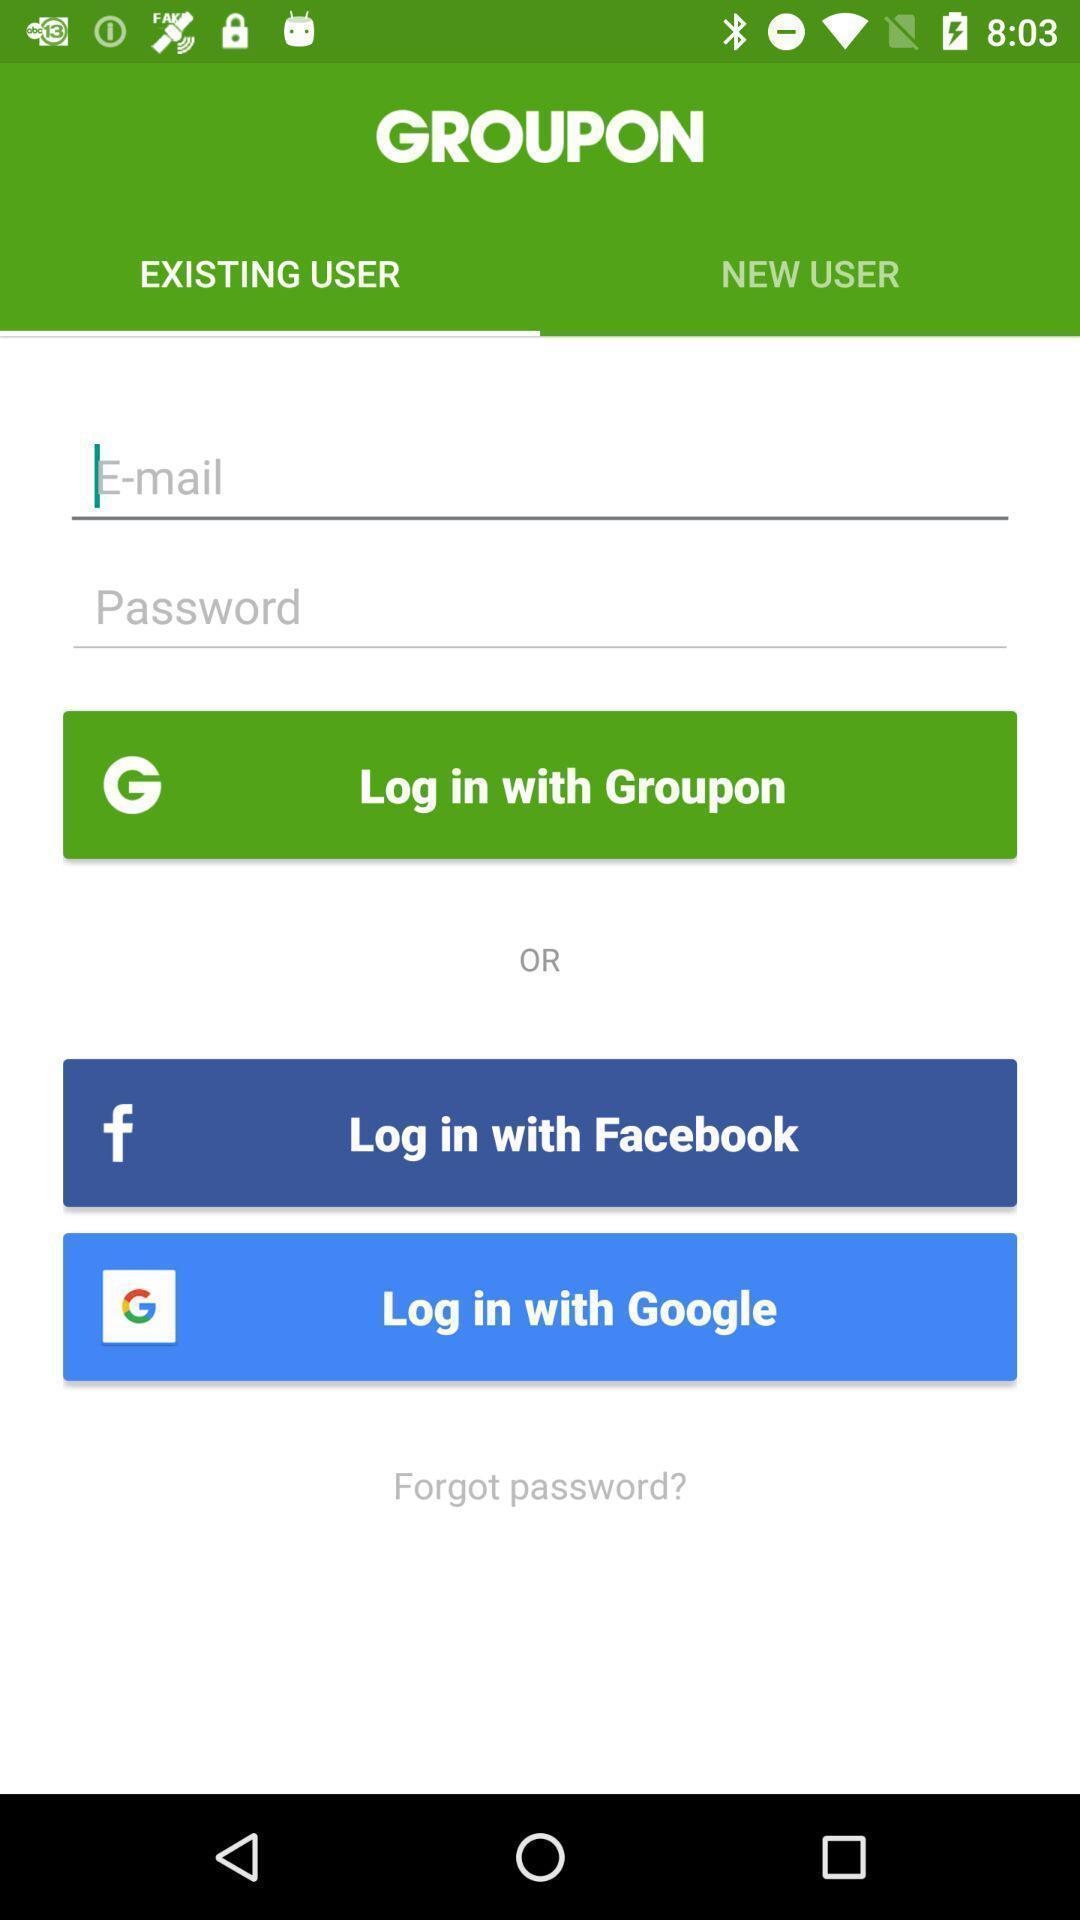Describe this image in words. Screen displaying multiple login options. 